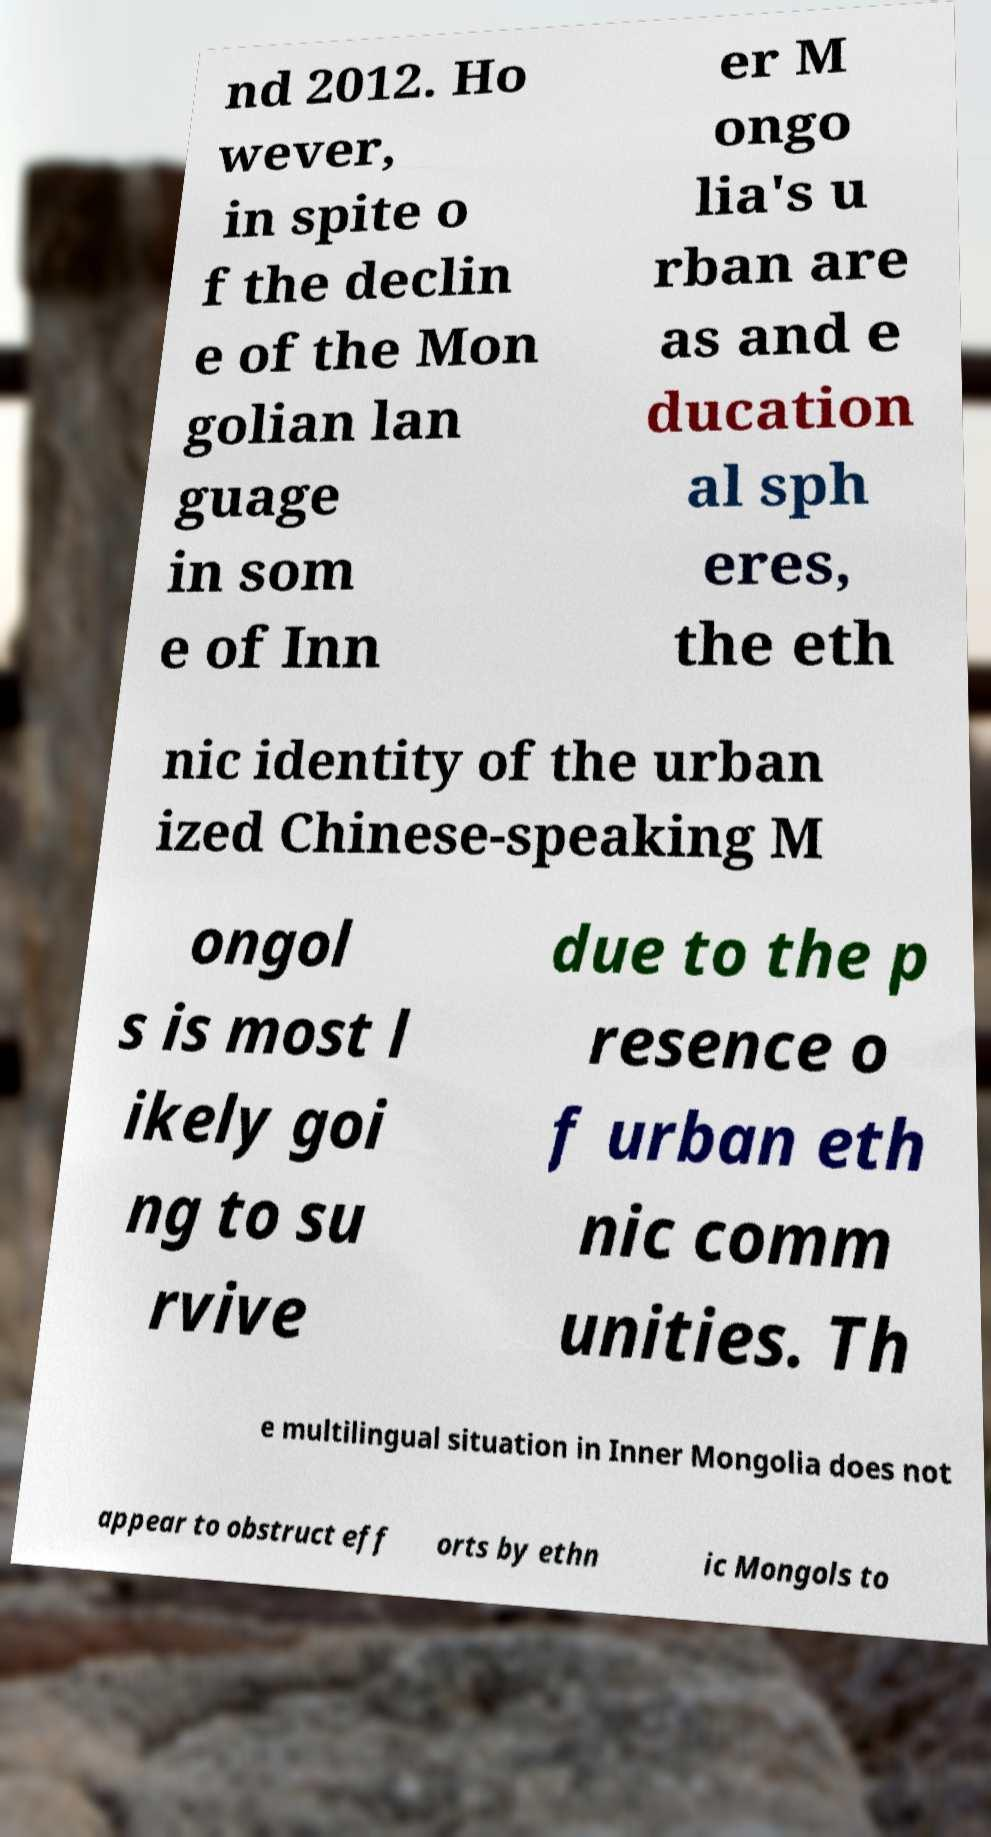I need the written content from this picture converted into text. Can you do that? nd 2012. Ho wever, in spite o f the declin e of the Mon golian lan guage in som e of Inn er M ongo lia's u rban are as and e ducation al sph eres, the eth nic identity of the urban ized Chinese-speaking M ongol s is most l ikely goi ng to su rvive due to the p resence o f urban eth nic comm unities. Th e multilingual situation in Inner Mongolia does not appear to obstruct eff orts by ethn ic Mongols to 